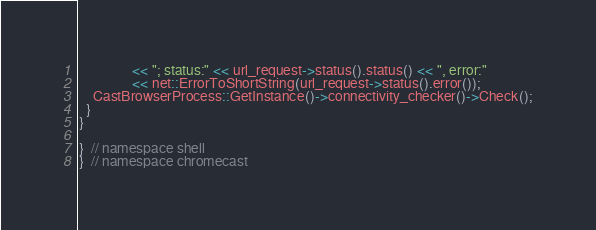<code> <loc_0><loc_0><loc_500><loc_500><_C++_>               << "; status:" << url_request->status().status() << ", error:"
               << net::ErrorToShortString(url_request->status().error());
    CastBrowserProcess::GetInstance()->connectivity_checker()->Check();
  }
}

}  // namespace shell
}  // namespace chromecast
</code> 